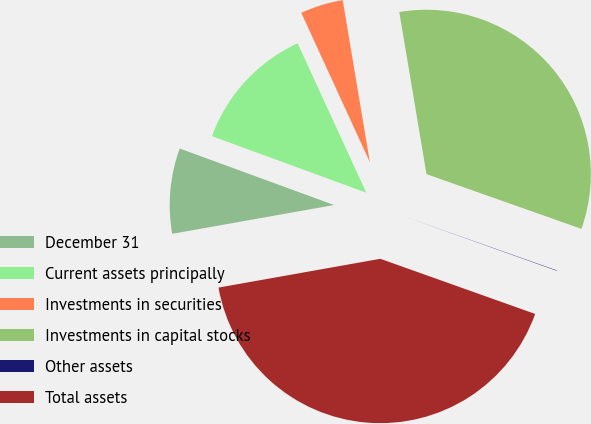<chart> <loc_0><loc_0><loc_500><loc_500><pie_chart><fcel>December 31<fcel>Current assets principally<fcel>Investments in securities<fcel>Investments in capital stocks<fcel>Other assets<fcel>Total assets<nl><fcel>8.39%<fcel>12.56%<fcel>4.21%<fcel>33.05%<fcel>0.04%<fcel>41.75%<nl></chart> 